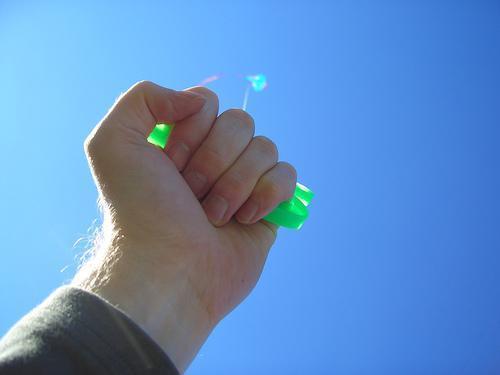How many hands are in the picture?
Give a very brief answer. 1. 